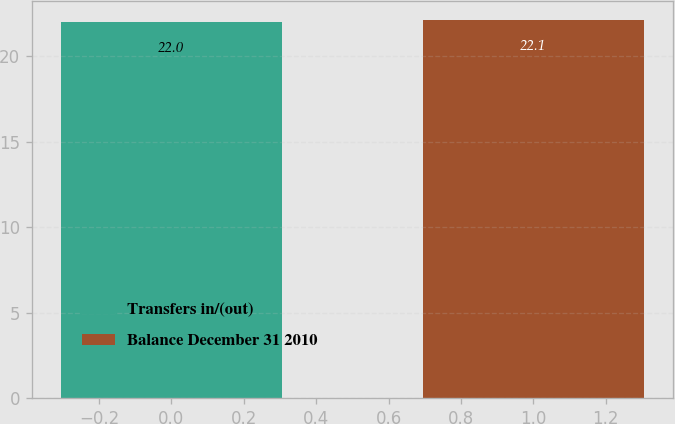Convert chart to OTSL. <chart><loc_0><loc_0><loc_500><loc_500><bar_chart><fcel>Transfers in/(out)<fcel>Balance December 31 2010<nl><fcel>22<fcel>22.1<nl></chart> 